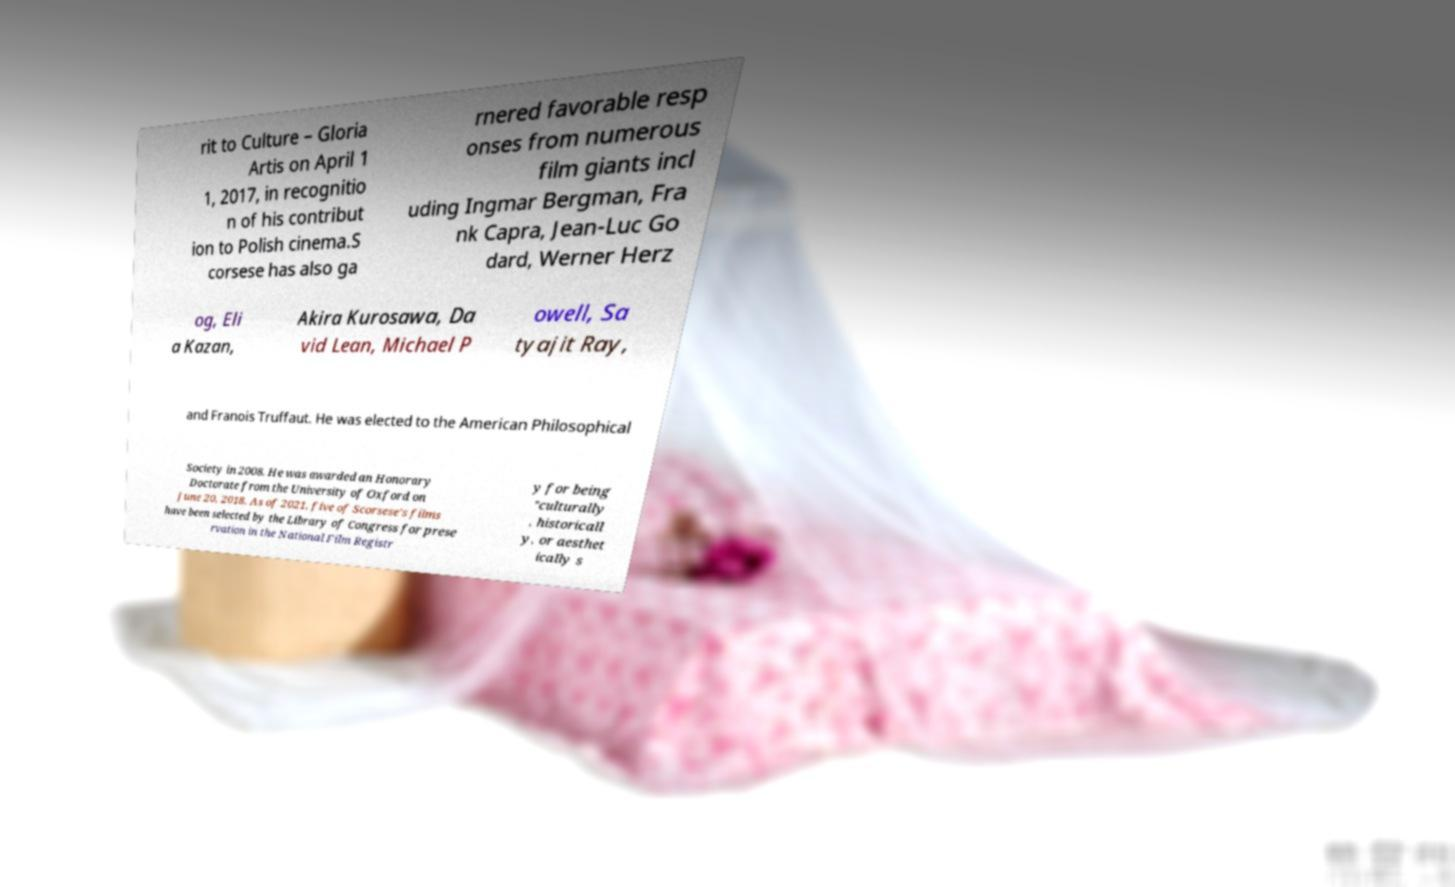Could you assist in decoding the text presented in this image and type it out clearly? rit to Culture – Gloria Artis on April 1 1, 2017, in recognitio n of his contribut ion to Polish cinema.S corsese has also ga rnered favorable resp onses from numerous film giants incl uding Ingmar Bergman, Fra nk Capra, Jean-Luc Go dard, Werner Herz og, Eli a Kazan, Akira Kurosawa, Da vid Lean, Michael P owell, Sa tyajit Ray, and Franois Truffaut. He was elected to the American Philosophical Society in 2008. He was awarded an Honorary Doctorate from the University of Oxford on June 20, 2018. As of 2021, five of Scorsese's films have been selected by the Library of Congress for prese rvation in the National Film Registr y for being "culturally , historicall y, or aesthet ically s 